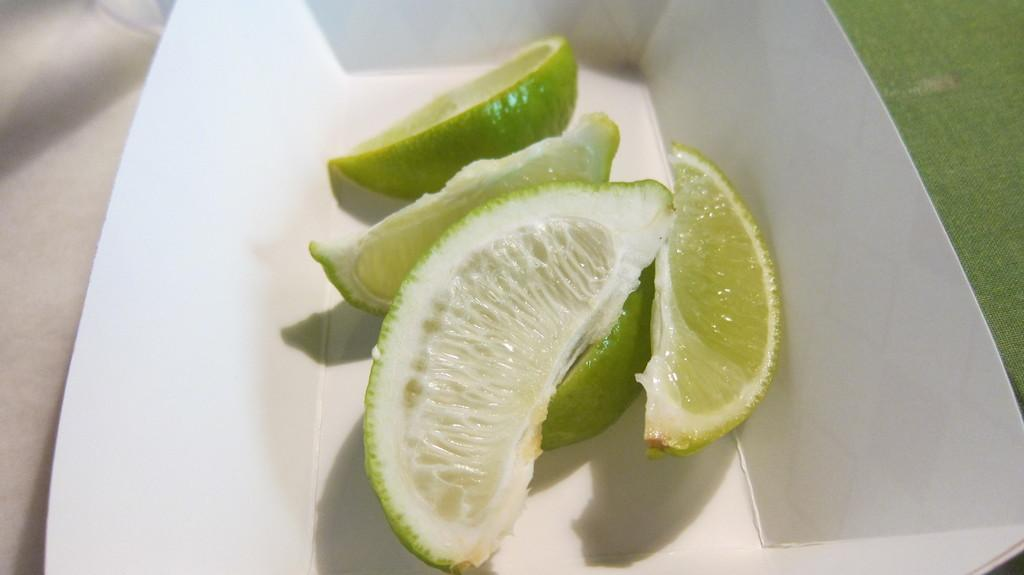What type of fruit is present in the image? There are Persian lime pieces in the image. How are the lime pieces contained in the image? The lime pieces are in a white box. What is the color of the box containing the lime pieces? The box is white. On what surface is the white box with lime pieces placed? The white box is on a surface. What type of paper is visible in the image? There is no paper present in the image; it features Persian lime pieces in a white box. What appliance is being used to process the lime pieces in the image? There is no appliance present in the image; it only shows lime pieces in a white box on a surface. 